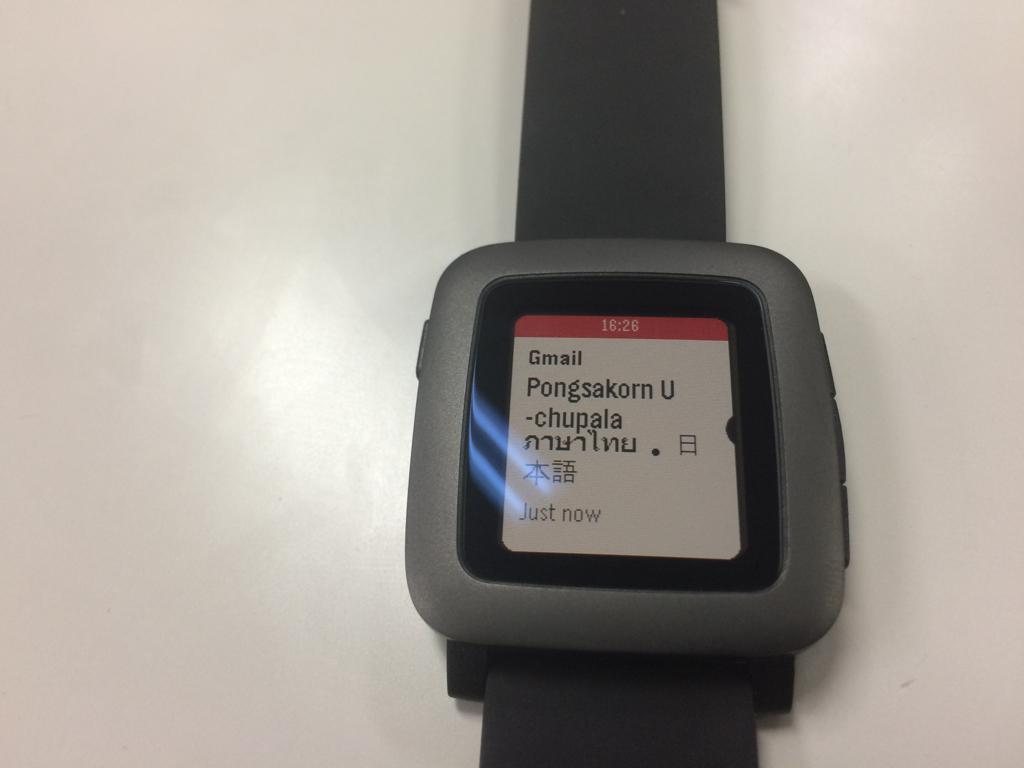<image>
Share a concise interpretation of the image provided. A watch screen displays an email in the Gmail app and the time of 16:26. 